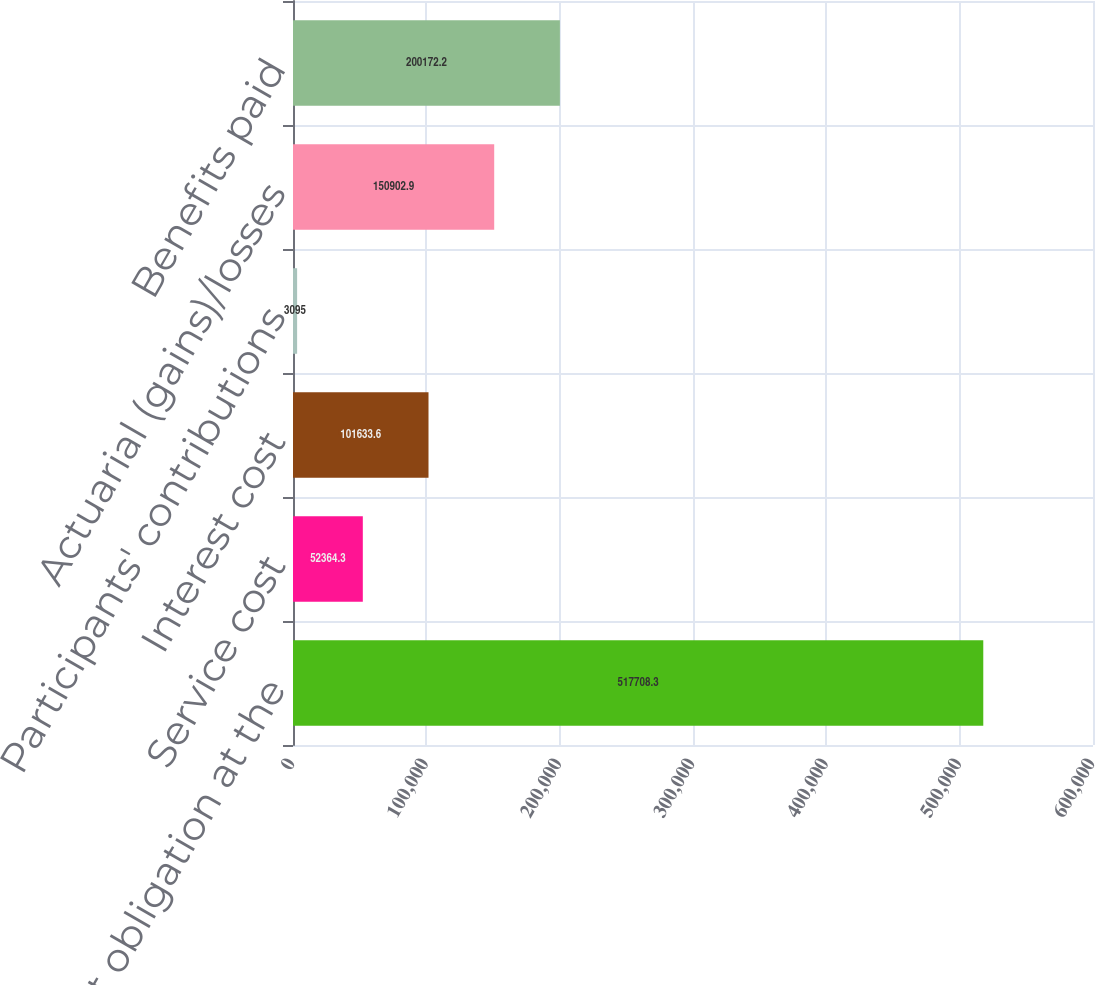Convert chart. <chart><loc_0><loc_0><loc_500><loc_500><bar_chart><fcel>Net benefit obligation at the<fcel>Service cost<fcel>Interest cost<fcel>Participants' contributions<fcel>Actuarial (gains)/losses<fcel>Benefits paid<nl><fcel>517708<fcel>52364.3<fcel>101634<fcel>3095<fcel>150903<fcel>200172<nl></chart> 